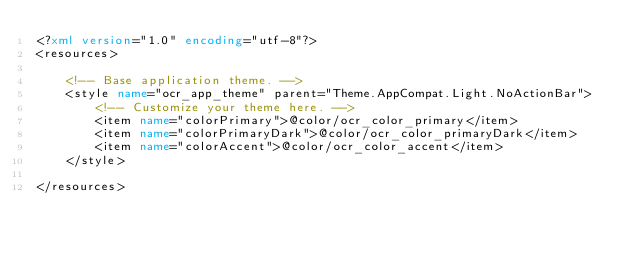<code> <loc_0><loc_0><loc_500><loc_500><_XML_><?xml version="1.0" encoding="utf-8"?>
<resources>

    <!-- Base application theme. -->
    <style name="ocr_app_theme" parent="Theme.AppCompat.Light.NoActionBar">
        <!-- Customize your theme here. -->
        <item name="colorPrimary">@color/ocr_color_primary</item>
        <item name="colorPrimaryDark">@color/ocr_color_primaryDark</item>
        <item name="colorAccent">@color/ocr_color_accent</item>
    </style>

</resources></code> 